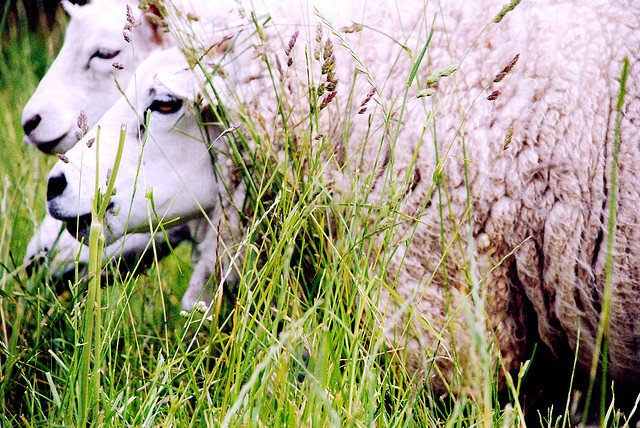Describe the objects in this image and their specific colors. I can see sheep in black, lavender, and darkgray tones, sheep in black, lavender, and darkgray tones, and sheep in black, lavender, darkgray, and gray tones in this image. 